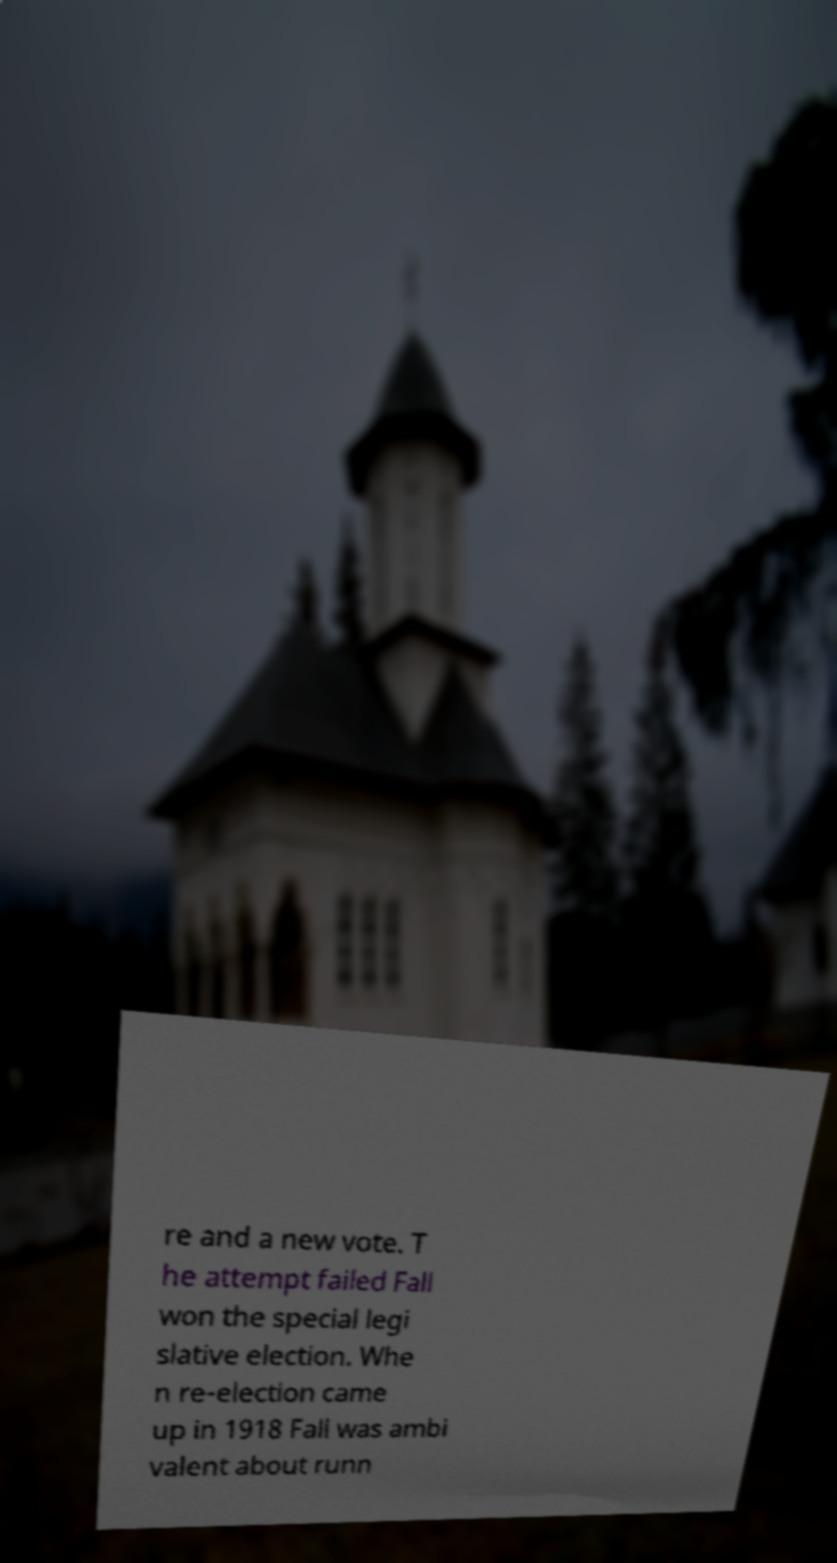What messages or text are displayed in this image? I need them in a readable, typed format. re and a new vote. T he attempt failed Fall won the special legi slative election. Whe n re-election came up in 1918 Fall was ambi valent about runn 